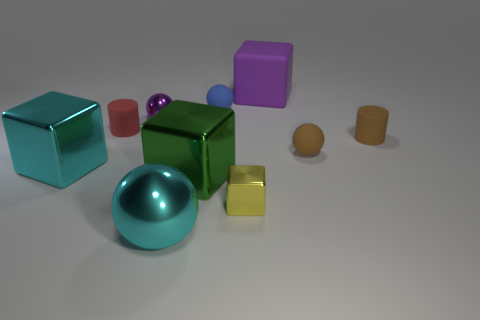The shiny object that is the same color as the big rubber cube is what shape?
Offer a terse response. Sphere. Are there an equal number of purple metallic things that are in front of the purple shiny object and small purple shiny objects that are right of the big cyan sphere?
Provide a short and direct response. Yes. There is a tiny thing that is the same shape as the big purple object; what color is it?
Offer a terse response. Yellow. Are there any other things that have the same shape as the yellow object?
Offer a very short reply. Yes. Is the color of the big thing right of the blue thing the same as the big ball?
Your response must be concise. No. There is a cyan thing that is the same shape as the tiny purple thing; what size is it?
Ensure brevity in your answer.  Large. How many small red cylinders are the same material as the cyan block?
Your response must be concise. 0. There is a purple rubber object that is behind the tiny ball that is on the right side of the large matte block; are there any big matte things in front of it?
Provide a succinct answer. No. The tiny purple object has what shape?
Your response must be concise. Sphere. Is the material of the small cylinder that is left of the yellow thing the same as the small sphere to the right of the blue object?
Offer a very short reply. Yes. 